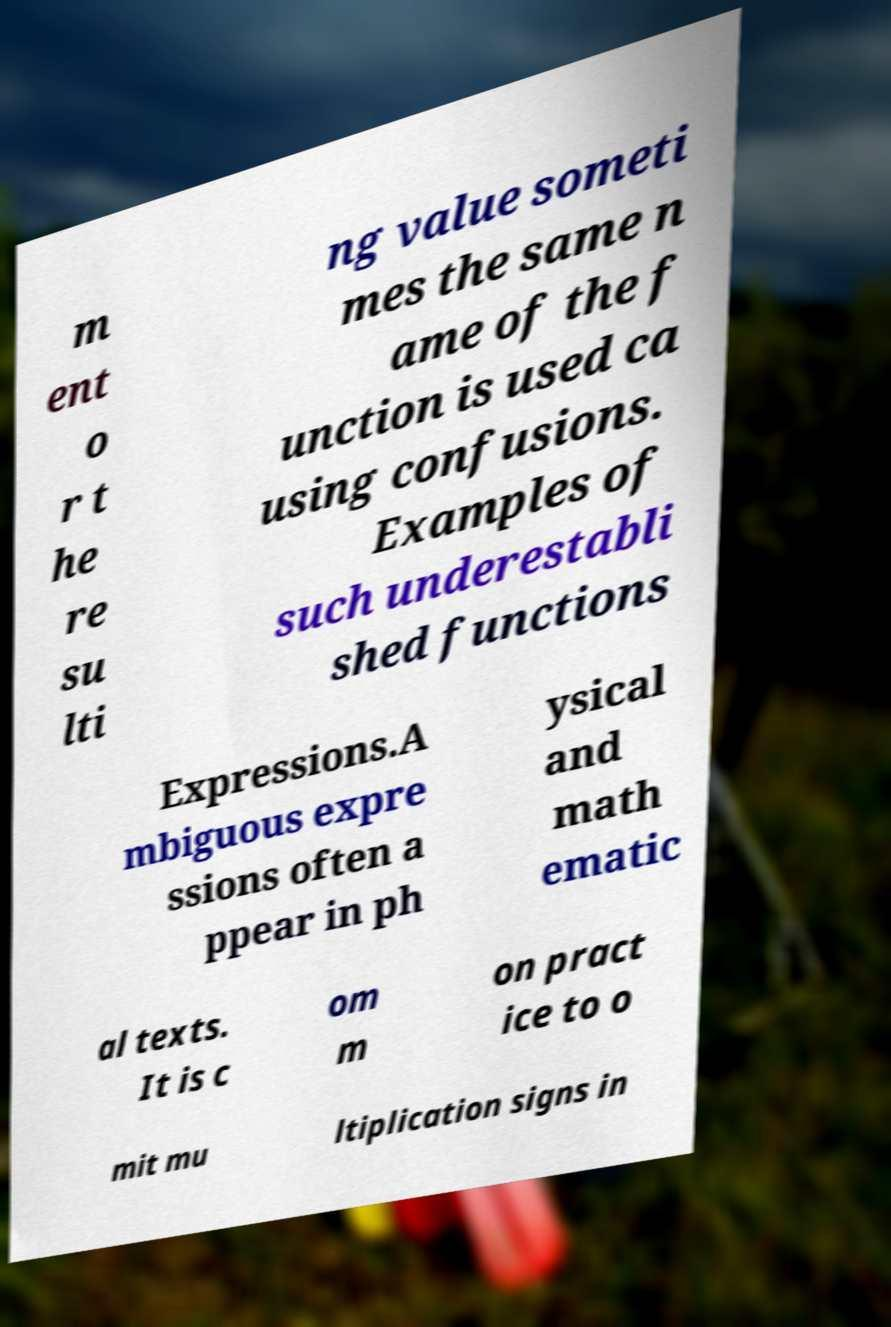Please identify and transcribe the text found in this image. m ent o r t he re su lti ng value someti mes the same n ame of the f unction is used ca using confusions. Examples of such underestabli shed functions Expressions.A mbiguous expre ssions often a ppear in ph ysical and math ematic al texts. It is c om m on pract ice to o mit mu ltiplication signs in 